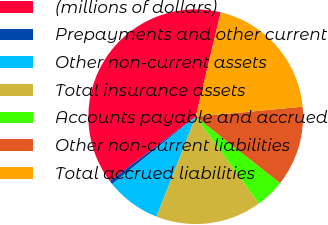Convert chart to OTSL. <chart><loc_0><loc_0><loc_500><loc_500><pie_chart><fcel>(millions of dollars)<fcel>Prepayments and other current<fcel>Other non-current assets<fcel>Total insurance assets<fcel>Accounts payable and accrued<fcel>Other non-current liabilities<fcel>Total accrued liabilities<nl><fcel>38.99%<fcel>0.56%<fcel>8.25%<fcel>15.93%<fcel>4.4%<fcel>12.09%<fcel>19.78%<nl></chart> 